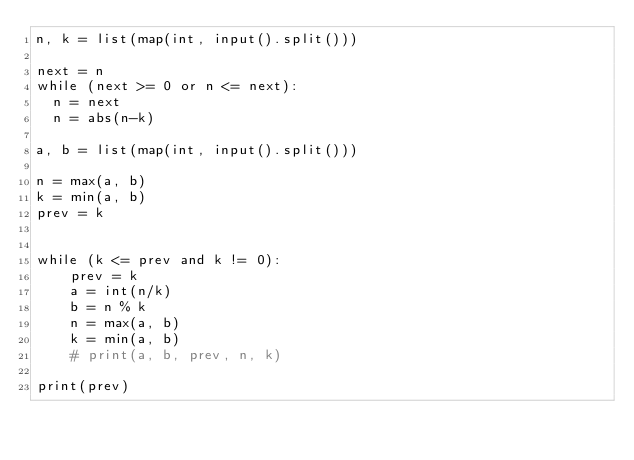Convert code to text. <code><loc_0><loc_0><loc_500><loc_500><_Python_>n, k = list(map(int, input().split()))

next = n
while (next >= 0 or n <= next): 
  n = next 
  n = abs(n-k)
 
a, b = list(map(int, input().split()))

n = max(a, b)
k = min(a, b)
prev = k


while (k <= prev and k != 0):
    prev = k
    a = int(n/k)
    b = n % k
    n = max(a, b)
    k = min(a, b)
    # print(a, b, prev, n, k)

print(prev)</code> 